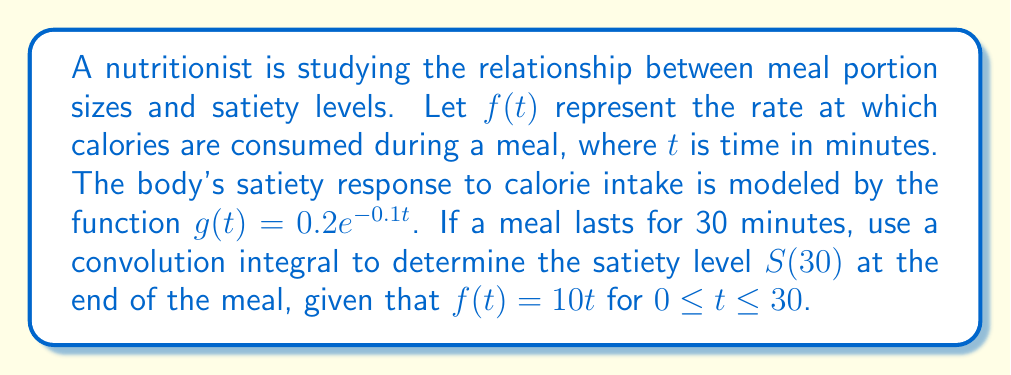Can you solve this math problem? To solve this problem, we'll use the convolution integral formula:

$$S(t) = (f * g)(t) = \int_0^t f(\tau)g(t-\tau)d\tau$$

Step 1: Set up the convolution integral for $S(30)$.
$$S(30) = \int_0^{30} f(\tau)g(30-\tau)d\tau$$

Step 2: Substitute the given functions.
$$S(30) = \int_0^{30} (10\tau)(0.2e^{-0.1(30-\tau)})d\tau$$

Step 3: Simplify the integrand.
$$S(30) = 2e^{-3}\int_0^{30} \tau e^{0.1\tau}d\tau$$

Step 4: Solve the integral using integration by parts. Let $u = \tau$ and $dv = e^{0.1\tau}d\tau$.
$$S(30) = 2e^{-3}\left[\frac{\tau e^{0.1\tau}}{0.1} - \int_0^{30} \frac{e^{0.1\tau}}{0.1}d\tau\right]_0^{30}$$

Step 5: Evaluate the integral.
$$S(30) = 2e^{-3}\left[\frac{30e^{3}}{0.1} - \frac{e^{3}}{0.01} + \frac{1}{0.01}\right]$$

Step 6: Simplify the expression.
$$S(30) = 20(300 - 100 + 1) = 4020$$

Therefore, the satiety level at the end of the 30-minute meal is 4020 units.
Answer: 4020 